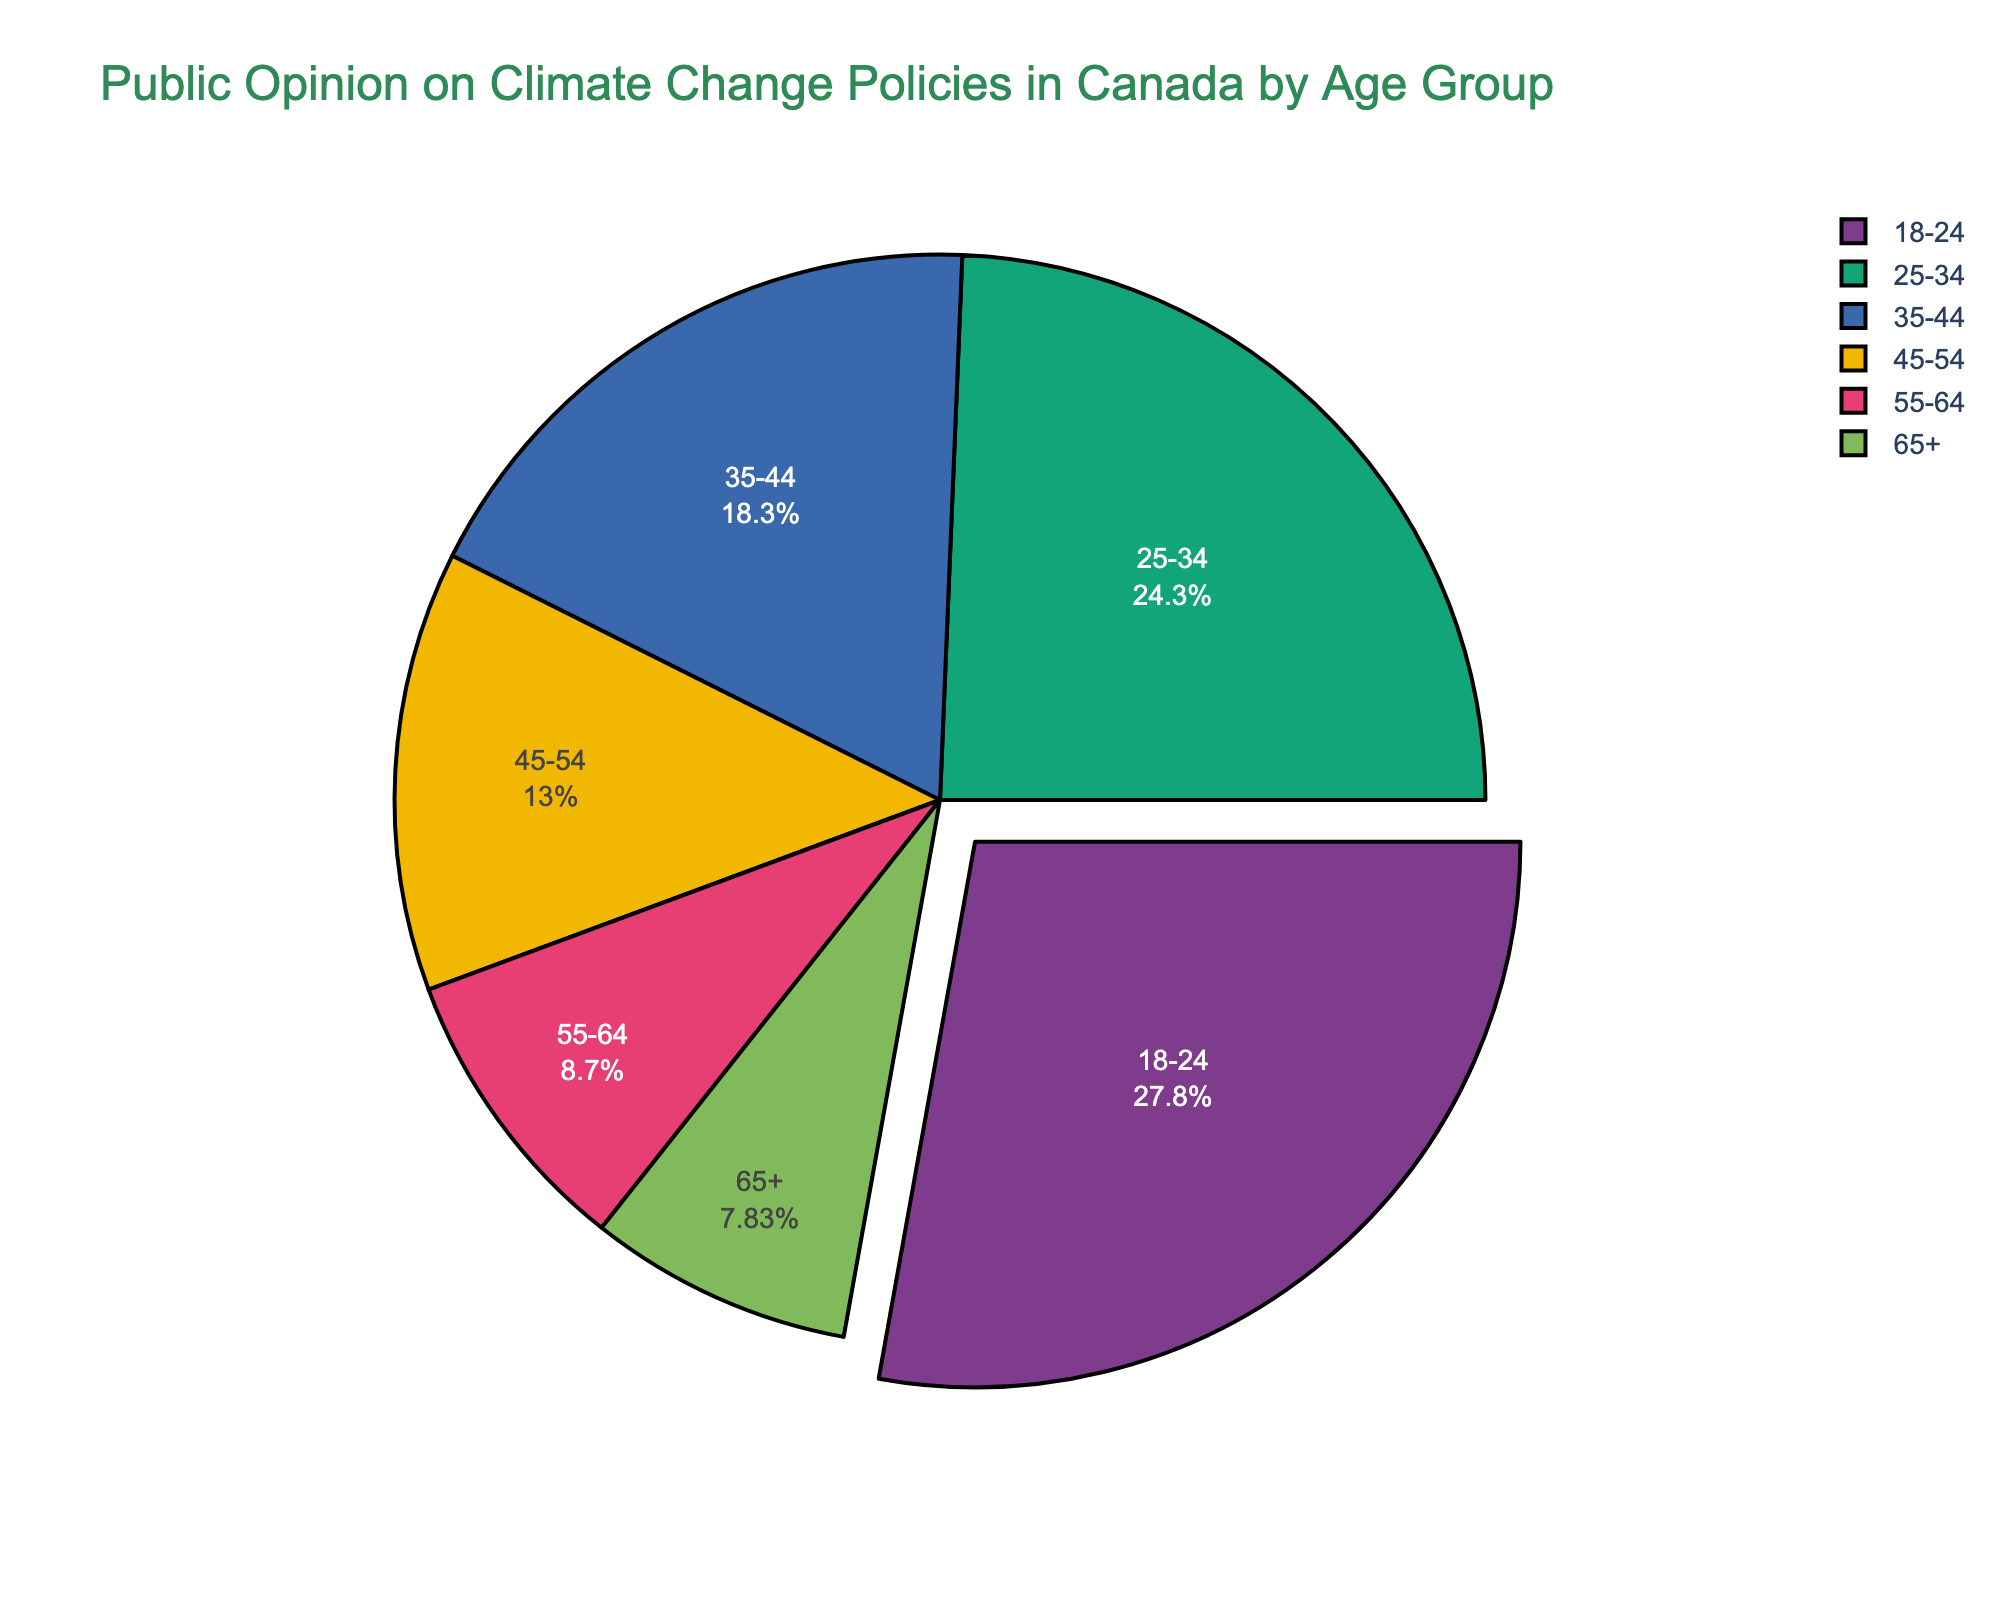What age group has the highest percentage of support for climate change policies? The pie chart shows that the 18-24 age group has the largest segment. This means they have the highest percentage of support.
Answer: 18-24 What is the combined percentage of support for climate change policies from the age groups 18-24 and 25-34? The percentage for 18-24 is 32%, and for 25-34 is 28%. Adding these together gives 32% + 28% = 60%.
Answer: 60% Which age group shows the least support for climate change policies? The pie chart displays the percentages for each age group, with the 65+ age group having the smallest segment, indicating the least support at 9%.
Answer: 65+ How much more support do the 18-24 age group show compared to the 55-64 age group? The pie chart indicates the support percentages are 32% for the 18-24 group and 10% for the 55-64 group. The difference is 32% - 10% = 22%.
Answer: 22% What is the average percentage of support for the age groups 35-44, 45-54, and 55-64? The percentages for these age groups are 21%, 15%, and 10%. Adding these together gives 21% + 15% + 10% = 46%. The average is 46% / 3 ≈ 15.33%.
Answer: 15.33% Are there more than two age groups that individually contribute less than 20% support? The pie chart indicates the percentages for each age group. The 35-44, 45-54, 55-64, and 65+ age groups each contribute less than 20%. That's four groups.
Answer: Yes Which color is used to represent the 18-24 age group in the pie chart? The visual attribute showing the highest percentage corresponds to the color representing the 18-24 age group. Assuming the standard palette, this would likely be a distinguishing color in the Bold sequence.
Answer: Green (assumed, visually similar bold colors) What is the total percentage of support for climate change policies from all age groups above 34 years old? The percentages for 35-44, 45-54, 55-64, and 65+ are 21%, 15%, 10%, and 9% respectively. Adding these together results in 21% + 15% + 10% + 9% = 55%.
Answer: 55% Is the support from the age group 25-34 higher than that from 35-44? The pie chart shows the percentage for 25-34 is 28% and for 35-44 is 21%. Comparing these, 28% is higher than 21%.
Answer: Yes How does the total combined support of the age groups 45-54 and 65+ compare to the support from the 18-24 age group alone? The pie chart shows 15% for 45-54 and 9% for 65+, combined as 15% + 9% = 24%. For 18-24, it is 32%. Comparing these, 24% is less than 32%.
Answer: Less 